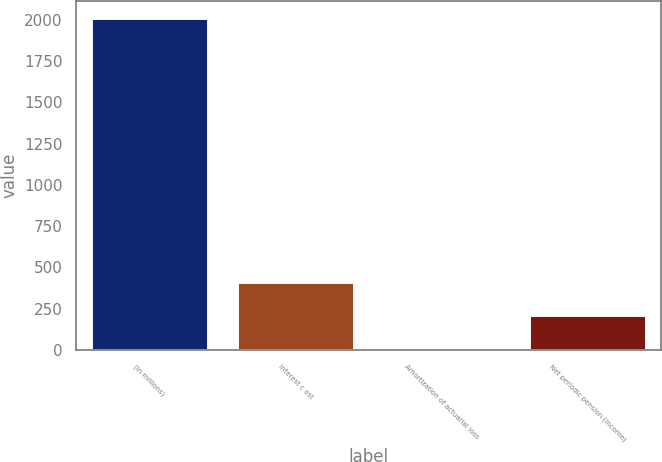<chart> <loc_0><loc_0><loc_500><loc_500><bar_chart><fcel>(in millions)<fcel>Interest c ost<fcel>Amortization of actuarial loss<fcel>Net periodic pension (income)<nl><fcel>2014<fcel>410<fcel>9<fcel>209.5<nl></chart> 